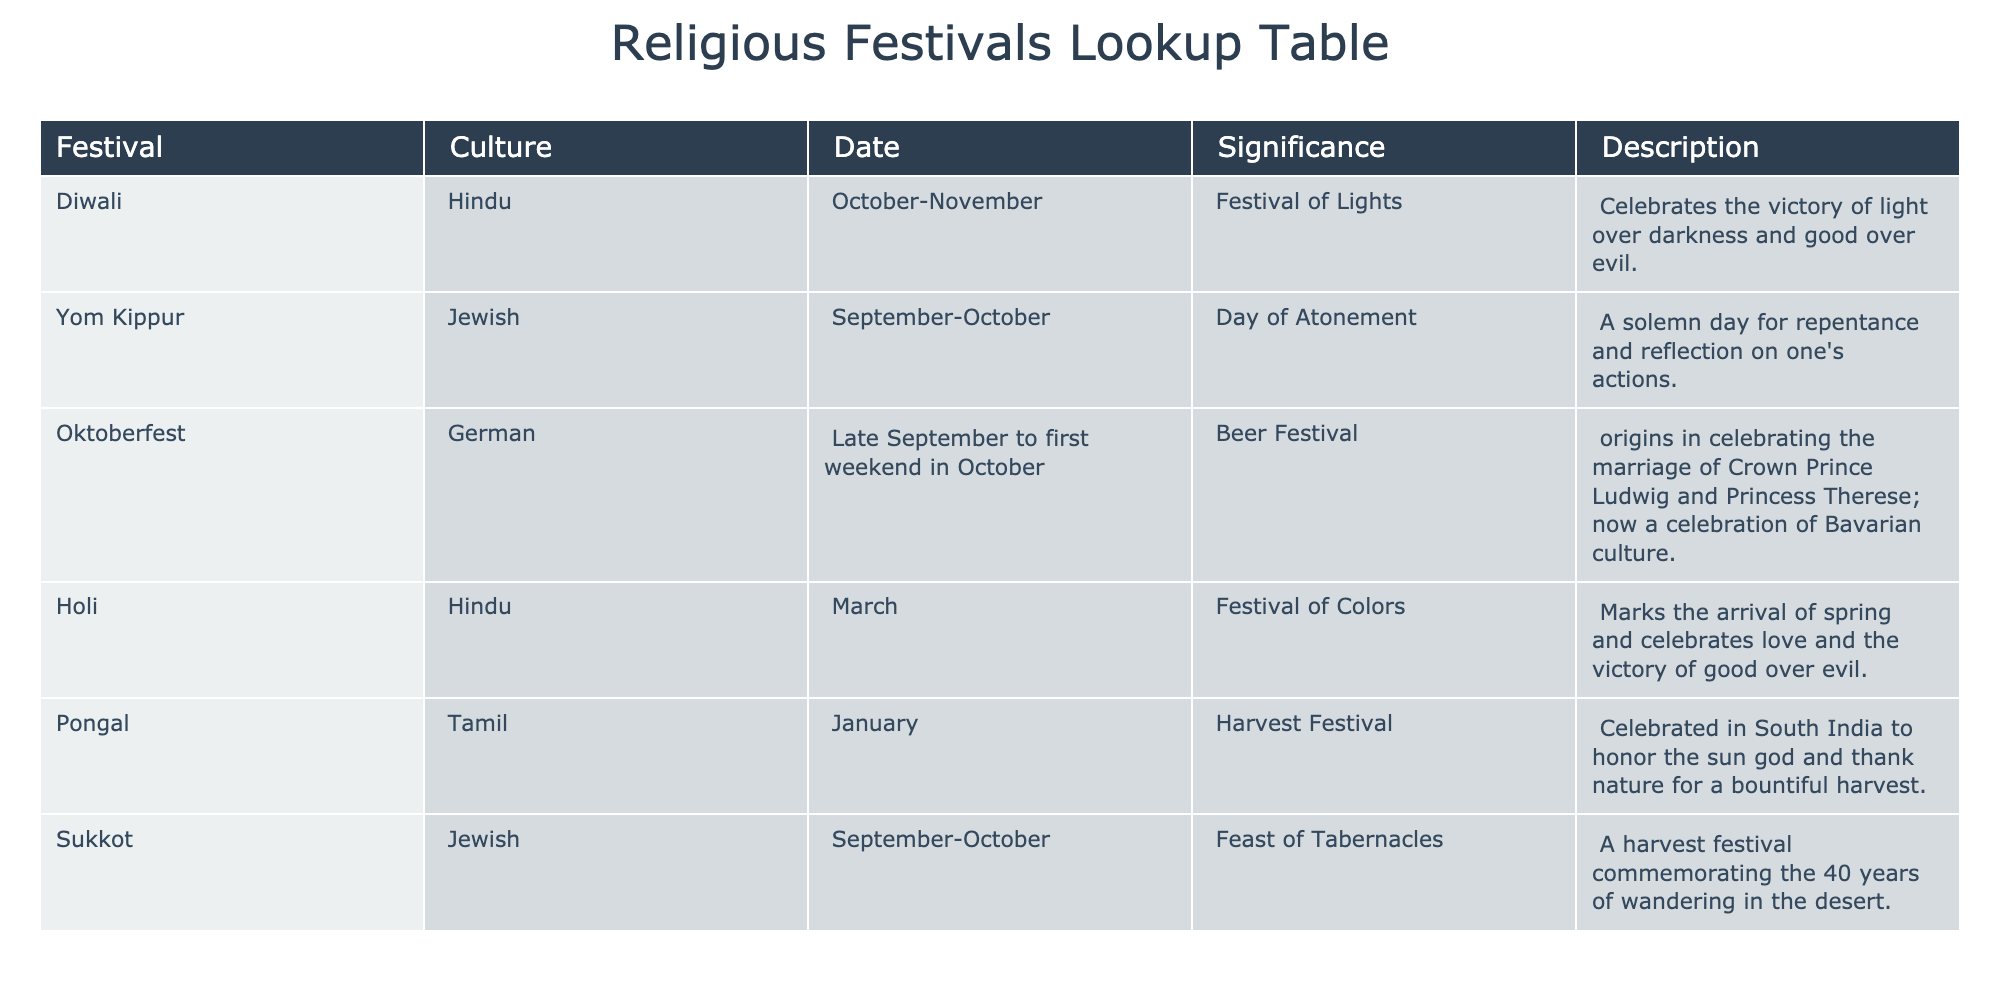What is the significance of Diwali? Diwali is noted in the table as the "Festival of Lights" and celebrates the victory of light over darkness and good over evil.
Answer: Festival of Lights Which festival occurs in January? By reviewing the table, Pongal is listed under the month of January.
Answer: Pongal How many Jewish festivals are listed in the table? The table includes two Jewish festivals: Yom Kippur and Sukkot. Thus, the total is two.
Answer: 2 What is the difference between the significance of Holi and Yom Kippur? Holi is described as marking the arrival of spring and celebrating love and the victory of good over evil, while Yom Kippur is a solemn day for reflection and repentance. Thus, they have different themes: celebration vs. atonement.
Answer: Celebration vs. Atonement Is Oktoberfest primarily a celebration of Bavarian culture? The table states that Oktoberfest originated as a celebration of the marriage of Crown Prince Ludwig and Princess Therese, but it is now mainly a celebration of Bavarian culture. Therefore, the statement is true.
Answer: Yes What month do the majority of Hindu festivals listed occur in? The table shows two Hindu festivals (Diwali and Holi). Diwali occurs in October-November and Holi in March. The majority (1 out of 2) are not in the same month; hence, no single month has a majority.
Answer: No month has a majority Which festivals are celebrated in the fall? From the table, Diwali (October-November), Yom Kippur (September-October), and Sukkot (September-October) fall in the autumn season. Thus, there are three festivals celebrated during this period.
Answer: 3 What is the significance of Sukkot? The significance of Sukkot is noted as a harvest festival that commemorates the 40 years of wandering in the desert.
Answer: Harvest festival commemorating wandering Which festival has the most descriptive significance in terms of seasonal change? Holi is linked to the arrival of spring and is explicitly described as marking this seasonal change, making it the most significant in terms of describing a seasonal transition.
Answer: Holi 